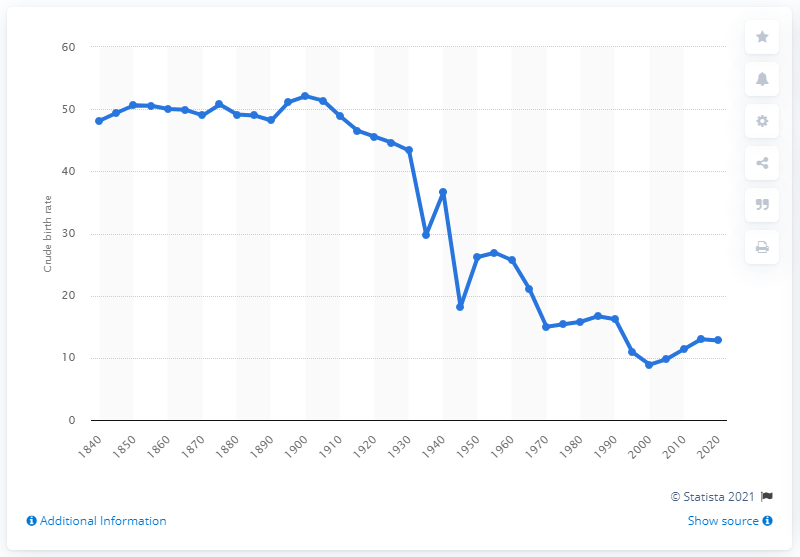Point out several critical features in this image. In the year 1990, the birth rate was 16.2. The expected crude birth rate for Russia in 2020 was 12.8. 